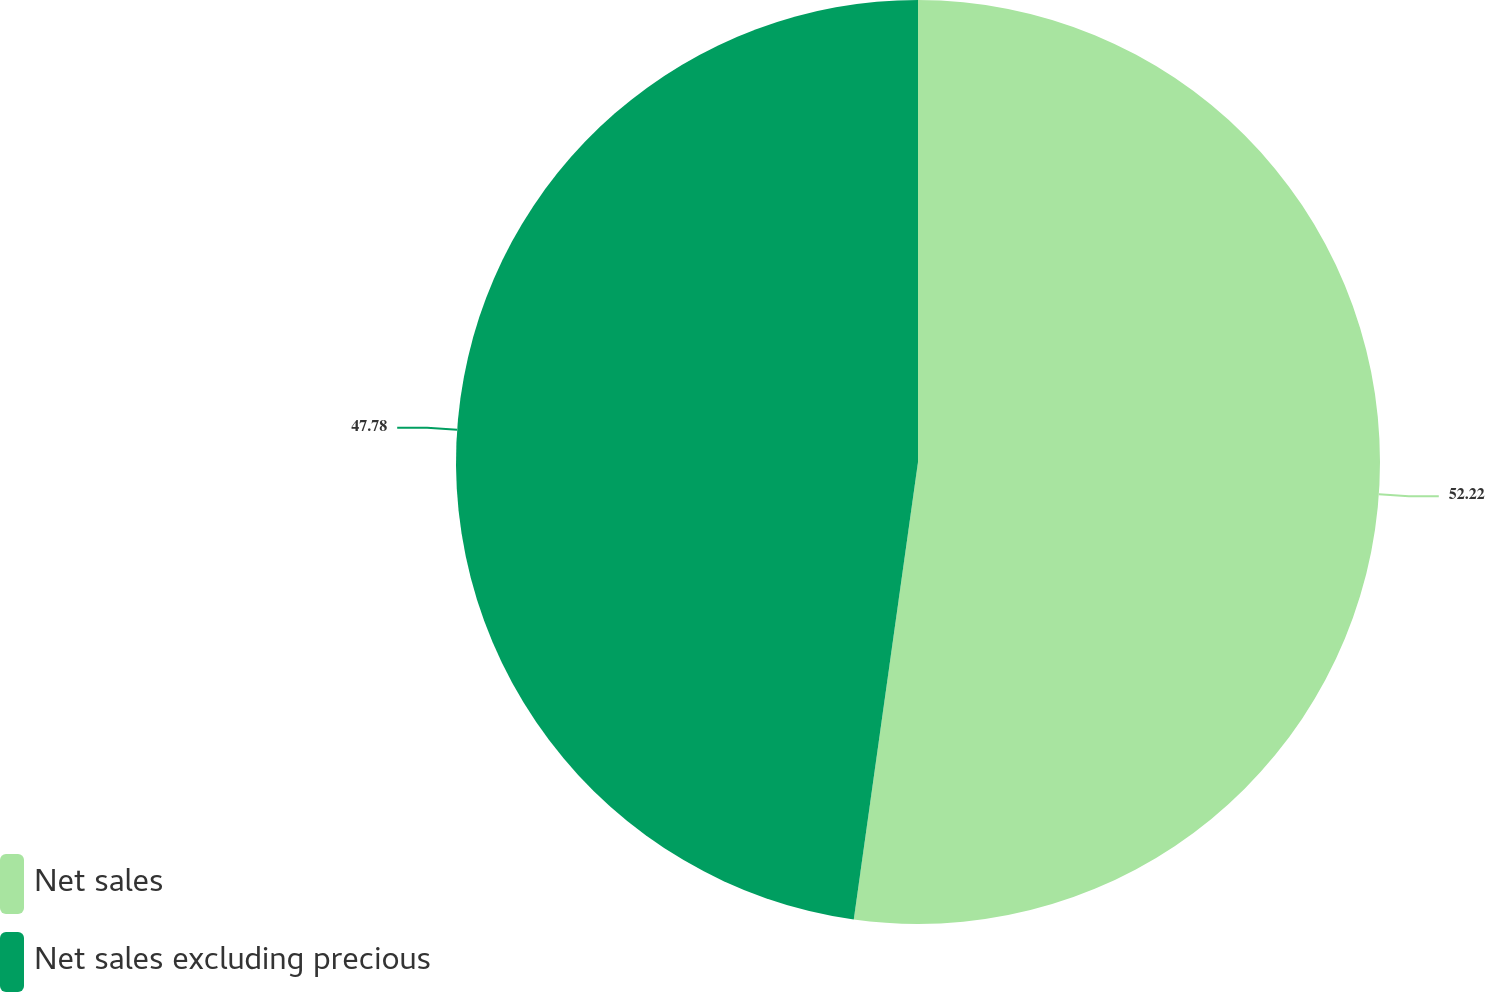Convert chart. <chart><loc_0><loc_0><loc_500><loc_500><pie_chart><fcel>Net sales<fcel>Net sales excluding precious<nl><fcel>52.22%<fcel>47.78%<nl></chart> 